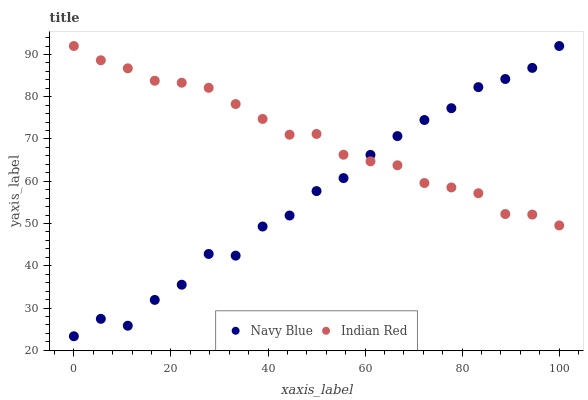Does Navy Blue have the minimum area under the curve?
Answer yes or no. Yes. Does Indian Red have the maximum area under the curve?
Answer yes or no. Yes. Does Indian Red have the minimum area under the curve?
Answer yes or no. No. Is Indian Red the smoothest?
Answer yes or no. Yes. Is Navy Blue the roughest?
Answer yes or no. Yes. Is Indian Red the roughest?
Answer yes or no. No. Does Navy Blue have the lowest value?
Answer yes or no. Yes. Does Indian Red have the lowest value?
Answer yes or no. No. Does Indian Red have the highest value?
Answer yes or no. Yes. Does Indian Red intersect Navy Blue?
Answer yes or no. Yes. Is Indian Red less than Navy Blue?
Answer yes or no. No. Is Indian Red greater than Navy Blue?
Answer yes or no. No. 